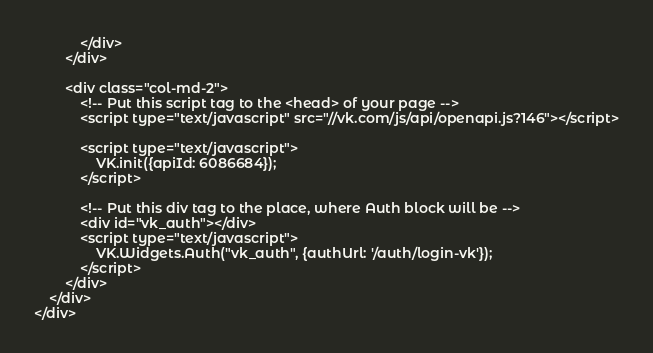<code> <loc_0><loc_0><loc_500><loc_500><_PHP_>            </div>
        </div>

        <div class="col-md-2">
            <!-- Put this script tag to the <head> of your page -->
            <script type="text/javascript" src="//vk.com/js/api/openapi.js?146"></script>

            <script type="text/javascript">
                VK.init({apiId: 6086684});
            </script>

            <!-- Put this div tag to the place, where Auth block will be -->
            <div id="vk_auth"></div>
            <script type="text/javascript">
                VK.Widgets.Auth("vk_auth", {authUrl: '/auth/login-vk'});
            </script>
        </div>
    </div>
</div>

</code> 